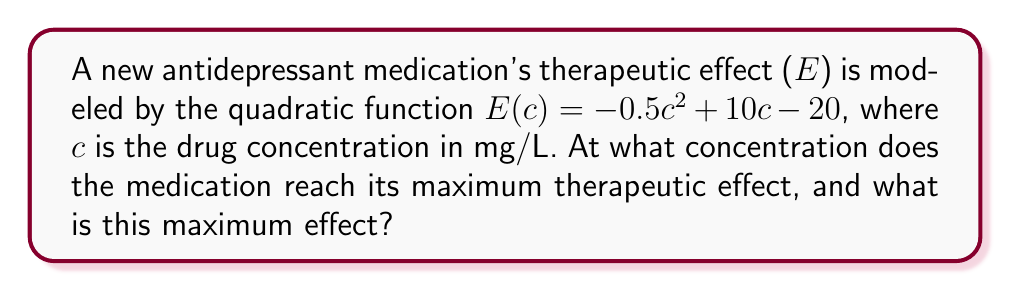Give your solution to this math problem. To find the maximum therapeutic effect and the concentration at which it occurs, we need to follow these steps:

1) The quadratic function is in the form $f(x) = ax^2 + bx + c$, where $a = -0.5$, $b = 10$, and $c = -20$.

2) For a quadratic function, the x-coordinate of the vertex represents the value of x where the function reaches its maximum (if $a < 0$) or minimum (if $a > 0$).

3) The formula for the x-coordinate of the vertex is $x = -\frac{b}{2a}$:

   $c = -\frac{10}{2(-0.5)} = -\frac{10}{-1} = 10$

4) So, the maximum therapeutic effect occurs at a concentration of 10 mg/L.

5) To find the maximum effect, we substitute this concentration back into the original function:

   $E(10) = -0.5(10)^2 + 10(10) - 20$
   $= -0.5(100) + 100 - 20$
   $= -50 + 100 - 20$
   $= 30$

Therefore, the maximum therapeutic effect is 30 units (the units depend on how effect is measured, e.g., percentage improvement in symptoms).
Answer: Concentration: 10 mg/L; Maximum effect: 30 units 